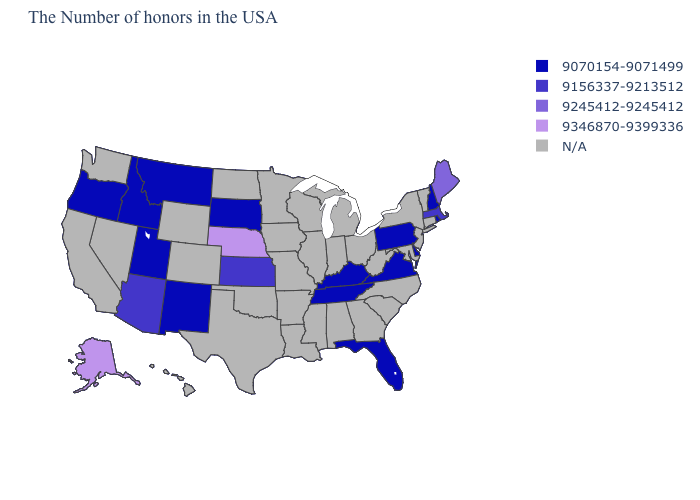Among the states that border Minnesota , which have the highest value?
Keep it brief. South Dakota. Which states have the lowest value in the USA?
Give a very brief answer. Rhode Island, New Hampshire, Delaware, Pennsylvania, Virginia, Florida, Kentucky, Tennessee, South Dakota, New Mexico, Utah, Montana, Idaho, Oregon. What is the value of South Carolina?
Be succinct. N/A. Name the states that have a value in the range N/A?
Quick response, please. Vermont, Connecticut, New York, New Jersey, Maryland, North Carolina, South Carolina, West Virginia, Ohio, Georgia, Michigan, Indiana, Alabama, Wisconsin, Illinois, Mississippi, Louisiana, Missouri, Arkansas, Minnesota, Iowa, Oklahoma, Texas, North Dakota, Wyoming, Colorado, Nevada, California, Washington, Hawaii. What is the value of Minnesota?
Write a very short answer. N/A. What is the highest value in the USA?
Answer briefly. 9346870-9399336. Name the states that have a value in the range N/A?
Give a very brief answer. Vermont, Connecticut, New York, New Jersey, Maryland, North Carolina, South Carolina, West Virginia, Ohio, Georgia, Michigan, Indiana, Alabama, Wisconsin, Illinois, Mississippi, Louisiana, Missouri, Arkansas, Minnesota, Iowa, Oklahoma, Texas, North Dakota, Wyoming, Colorado, Nevada, California, Washington, Hawaii. Which states hav the highest value in the Northeast?
Keep it brief. Maine. Does the first symbol in the legend represent the smallest category?
Keep it brief. Yes. What is the lowest value in the USA?
Write a very short answer. 9070154-9071499. Among the states that border Oklahoma , which have the highest value?
Keep it brief. Kansas. Does the first symbol in the legend represent the smallest category?
Concise answer only. Yes. 